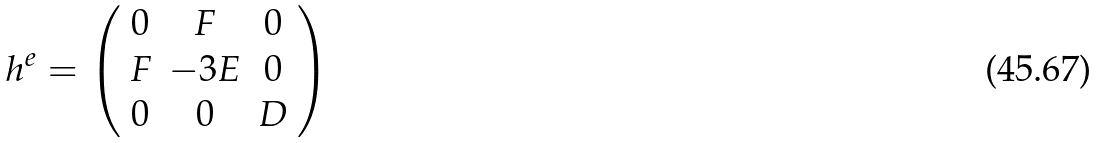Convert formula to latex. <formula><loc_0><loc_0><loc_500><loc_500>h ^ { e } = \left ( \begin{array} { c c c } 0 & F & 0 \\ F & - 3 E & 0 \\ 0 & 0 & D \end{array} \right )</formula> 